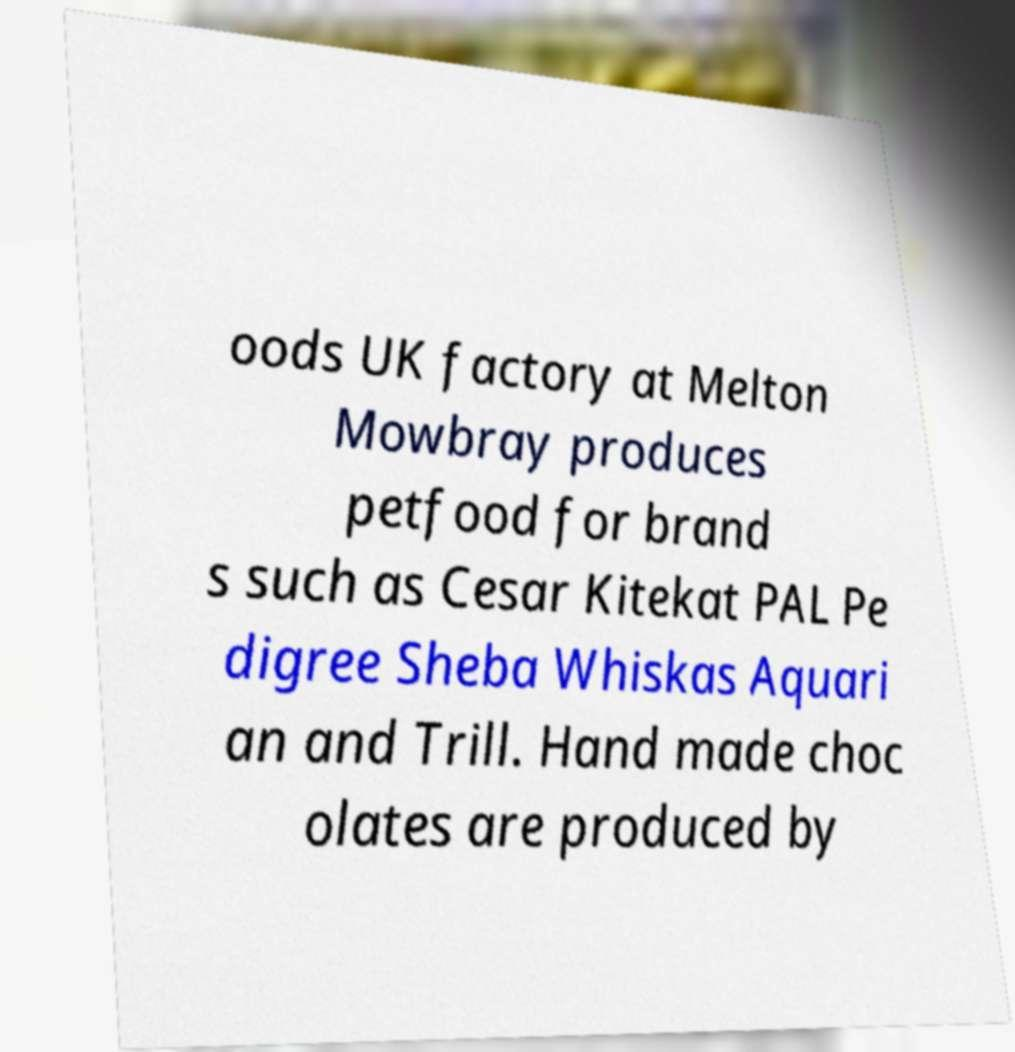Can you accurately transcribe the text from the provided image for me? oods UK factory at Melton Mowbray produces petfood for brand s such as Cesar Kitekat PAL Pe digree Sheba Whiskas Aquari an and Trill. Hand made choc olates are produced by 